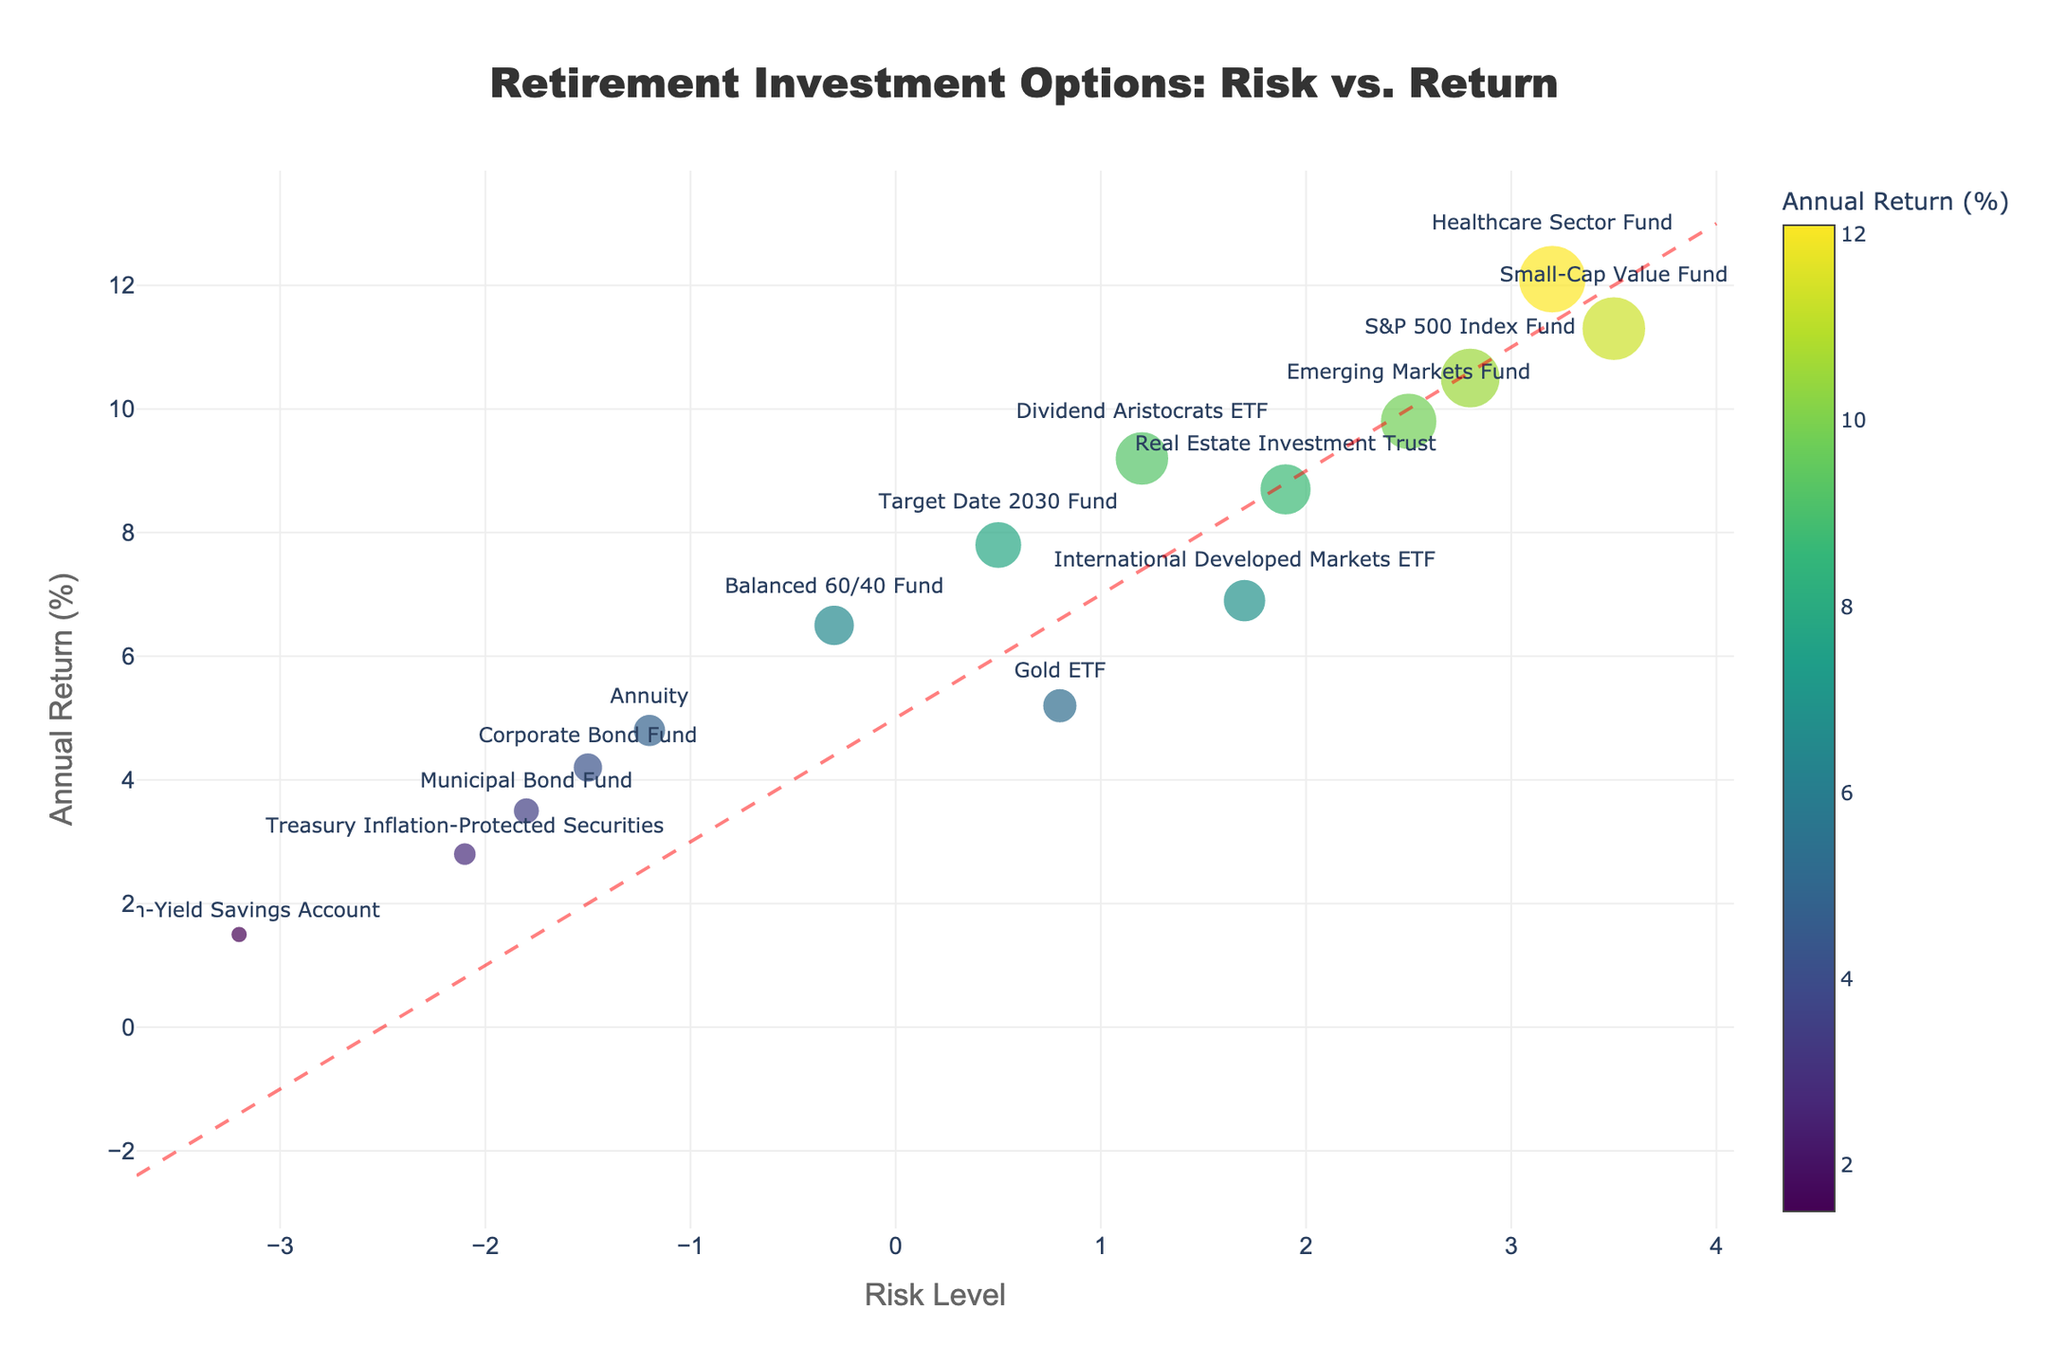What is the title of the figure? The title is generally located at the top center of the plot, often in larger and bold font. In this case, the title is 'Retirement Investment Options: Risk vs. Return'.
Answer: Retirement Investment Options: Risk vs. Return How many investment options show negative risk levels? Risk level values on the x-axis depict the risk levels. Count the points on the left side of the vertical zero line, which are 5 (Corporate Bond Fund, High-Yield Savings Account, Treasury Inflation-Protected Securities, Balanced 60/40 Fund, and Municipal Bond Fund).
Answer: 5 Which investment option has the highest annual return and what is the value? Identify the highest point on the y-axis. The highest point corresponds to the Healthcare Sector Fund with an annual return of 12.1%.
Answer: Healthcare Sector Fund, 12.1% Which investment options have a risk level between -1 and 1? Look for points situated between -1 and 1 on the x-axis. The investment options within this range are Corporate Bond Fund, Target Date 2030 Fund, Dividend Aristocrats ETF, Balanced 60/40 Fund, Gold ETF, and Annuity.
Answer: Corporate Bond Fund, Target Date 2030 Fund, Dividend Aristocrats ETF, Balanced 60/40 Fund, Gold ETF, and Annuity What is the range of annual returns for investment options with a risk level greater than 2? Identify the points to the right of 2 on the x-axis. The annual returns for these points are Small-Cap Value Fund (11.3%), Healthcare Sector Fund (12.1%), and Emerging Markets Fund (9.8%). The range is from 9.8% to 12.1%.
Answer: 9.8% to 12.1% Which investment option exhibits the lowest risk level, and what is its annual return? Locate the point farthest to the left on the x-axis. The lowest risk level corresponds to the High-Yield Savings Account with an annual return of 1.5%.
Answer: High-Yield Savings Account, 1.5% Which data point is closest to the origin (0,0) and what does it represent in terms of investment option, annual return, and risk level? The point nearest to the intersection of the x-axis and y-axis represents the Balanced 60/40 Fund with an annual return of 6.5% and a risk level of -0.3%.
Answer: Balanced 60/40 Fund, 6.5%, -0.3 How many points lie above the diagonal risk-return tradeoff line? Identify the diagonal line and count the number of points above it. These points are: S&P 500 Index Fund, Real Estate Investment Trust, Target Date 2030 Fund, Dividend Aristocrats ETF, Small-Cap Value Fund, Emerging Markets Fund, and Healthcare Sector Fund. There are 7 points above this line.
Answer: 7 Which investment option has the lowest annual return, and what is its risk level? Find the lowest point on the y-axis. The lowest annual return corresponds to the High-Yield Savings Account with an annual return of 1.5% and a risk level of -3.2.
Answer: High-Yield Savings Account, -3.2 Of the options with a positive risk level, which two have the closest annual returns? Compare the annual returns of options with positive risk levels, which are S&P 500 Index Fund (10.5%), Real Estate Investment Trust (8.7%), Target Date 2030 Fund (7.8%), Dividend Aristocrats ETF (9.2%), Small-Cap Value Fund (11.3%), Emerging Markets Fund (9.8%), International Developed Markets ETF (6.9%), and Healthcare Sector Fund (12.1%). The closest values are Dividend Aristocrats ETF (9.2%) and Emerging Markets Fund (9.8%), with a difference of 0.6.
Answer: Dividend Aristocrats ETF and Emerging Markets Fund, difference of 0.6 